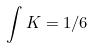<formula> <loc_0><loc_0><loc_500><loc_500>\int K = 1 / 6</formula> 